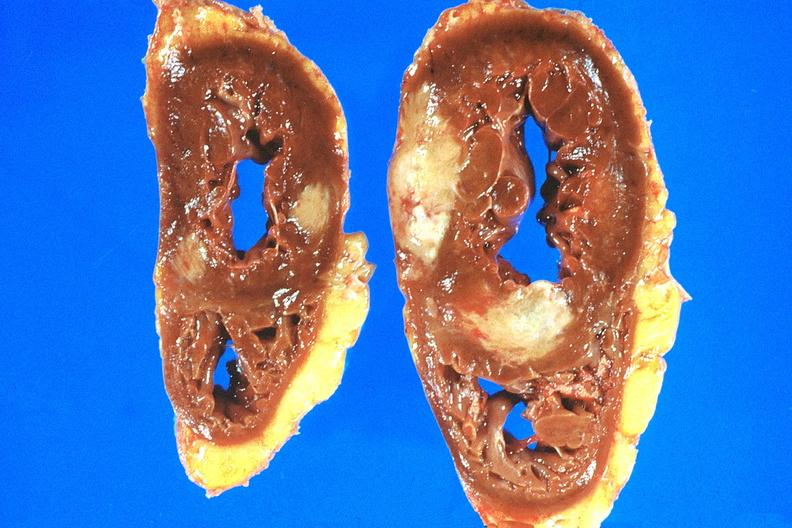does this image show heart, metastatic mesothelioma?
Answer the question using a single word or phrase. Yes 